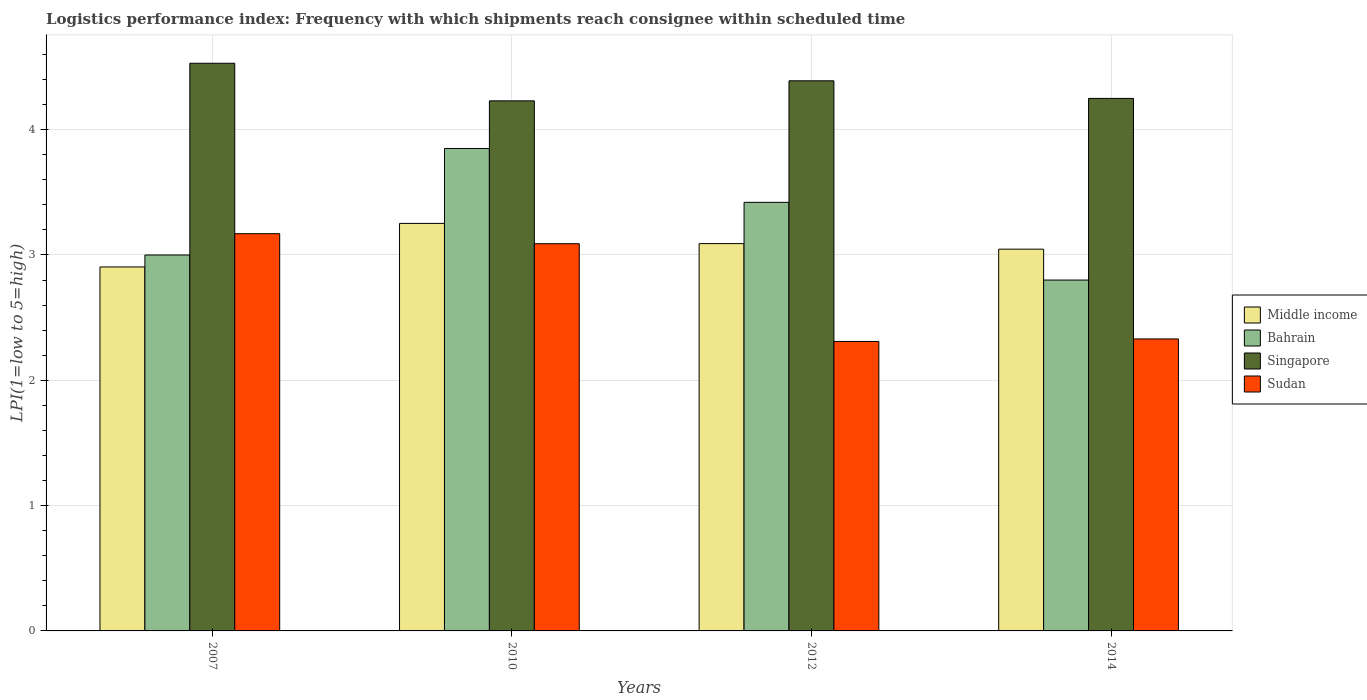How many different coloured bars are there?
Your answer should be very brief. 4. Are the number of bars per tick equal to the number of legend labels?
Provide a succinct answer. Yes. Are the number of bars on each tick of the X-axis equal?
Your response must be concise. Yes. In how many cases, is the number of bars for a given year not equal to the number of legend labels?
Your answer should be very brief. 0. What is the logistics performance index in Singapore in 2010?
Keep it short and to the point. 4.23. Across all years, what is the maximum logistics performance index in Sudan?
Your answer should be very brief. 3.17. Across all years, what is the minimum logistics performance index in Sudan?
Provide a short and direct response. 2.31. What is the total logistics performance index in Sudan in the graph?
Offer a terse response. 10.9. What is the difference between the logistics performance index in Sudan in 2012 and that in 2014?
Keep it short and to the point. -0.02. What is the difference between the logistics performance index in Middle income in 2014 and the logistics performance index in Singapore in 2012?
Offer a terse response. -1.34. What is the average logistics performance index in Sudan per year?
Provide a succinct answer. 2.73. In the year 2007, what is the difference between the logistics performance index in Middle income and logistics performance index in Bahrain?
Your answer should be compact. -0.1. In how many years, is the logistics performance index in Bahrain greater than 3?
Provide a short and direct response. 2. What is the ratio of the logistics performance index in Middle income in 2012 to that in 2014?
Provide a succinct answer. 1.01. Is the logistics performance index in Singapore in 2007 less than that in 2012?
Keep it short and to the point. No. What is the difference between the highest and the second highest logistics performance index in Middle income?
Offer a very short reply. 0.16. What is the difference between the highest and the lowest logistics performance index in Singapore?
Your response must be concise. 0.3. Is the sum of the logistics performance index in Singapore in 2007 and 2010 greater than the maximum logistics performance index in Bahrain across all years?
Provide a succinct answer. Yes. Is it the case that in every year, the sum of the logistics performance index in Sudan and logistics performance index in Singapore is greater than the sum of logistics performance index in Bahrain and logistics performance index in Middle income?
Your response must be concise. Yes. What does the 2nd bar from the left in 2010 represents?
Keep it short and to the point. Bahrain. What does the 2nd bar from the right in 2012 represents?
Offer a terse response. Singapore. Is it the case that in every year, the sum of the logistics performance index in Sudan and logistics performance index in Bahrain is greater than the logistics performance index in Singapore?
Offer a very short reply. Yes. How many bars are there?
Provide a short and direct response. 16. Are the values on the major ticks of Y-axis written in scientific E-notation?
Offer a terse response. No. Does the graph contain grids?
Your answer should be compact. Yes. How are the legend labels stacked?
Offer a very short reply. Vertical. What is the title of the graph?
Make the answer very short. Logistics performance index: Frequency with which shipments reach consignee within scheduled time. What is the label or title of the X-axis?
Provide a succinct answer. Years. What is the label or title of the Y-axis?
Your answer should be very brief. LPI(1=low to 5=high). What is the LPI(1=low to 5=high) of Middle income in 2007?
Ensure brevity in your answer.  2.9. What is the LPI(1=low to 5=high) of Bahrain in 2007?
Your answer should be very brief. 3. What is the LPI(1=low to 5=high) of Singapore in 2007?
Your answer should be very brief. 4.53. What is the LPI(1=low to 5=high) in Sudan in 2007?
Provide a short and direct response. 3.17. What is the LPI(1=low to 5=high) in Middle income in 2010?
Your response must be concise. 3.25. What is the LPI(1=low to 5=high) of Bahrain in 2010?
Your answer should be very brief. 3.85. What is the LPI(1=low to 5=high) in Singapore in 2010?
Provide a short and direct response. 4.23. What is the LPI(1=low to 5=high) in Sudan in 2010?
Offer a terse response. 3.09. What is the LPI(1=low to 5=high) of Middle income in 2012?
Your answer should be compact. 3.09. What is the LPI(1=low to 5=high) in Bahrain in 2012?
Make the answer very short. 3.42. What is the LPI(1=low to 5=high) in Singapore in 2012?
Provide a succinct answer. 4.39. What is the LPI(1=low to 5=high) of Sudan in 2012?
Your answer should be compact. 2.31. What is the LPI(1=low to 5=high) of Middle income in 2014?
Ensure brevity in your answer.  3.05. What is the LPI(1=low to 5=high) of Bahrain in 2014?
Provide a succinct answer. 2.8. What is the LPI(1=low to 5=high) in Singapore in 2014?
Make the answer very short. 4.25. What is the LPI(1=low to 5=high) in Sudan in 2014?
Your answer should be very brief. 2.33. Across all years, what is the maximum LPI(1=low to 5=high) in Middle income?
Your response must be concise. 3.25. Across all years, what is the maximum LPI(1=low to 5=high) of Bahrain?
Your answer should be compact. 3.85. Across all years, what is the maximum LPI(1=low to 5=high) in Singapore?
Make the answer very short. 4.53. Across all years, what is the maximum LPI(1=low to 5=high) of Sudan?
Offer a terse response. 3.17. Across all years, what is the minimum LPI(1=low to 5=high) in Middle income?
Your answer should be compact. 2.9. Across all years, what is the minimum LPI(1=low to 5=high) of Bahrain?
Provide a short and direct response. 2.8. Across all years, what is the minimum LPI(1=low to 5=high) in Singapore?
Give a very brief answer. 4.23. Across all years, what is the minimum LPI(1=low to 5=high) in Sudan?
Offer a terse response. 2.31. What is the total LPI(1=low to 5=high) in Middle income in the graph?
Your answer should be compact. 12.29. What is the total LPI(1=low to 5=high) in Bahrain in the graph?
Your answer should be compact. 13.07. What is the total LPI(1=low to 5=high) in Singapore in the graph?
Your answer should be compact. 17.4. What is the total LPI(1=low to 5=high) of Sudan in the graph?
Make the answer very short. 10.9. What is the difference between the LPI(1=low to 5=high) of Middle income in 2007 and that in 2010?
Make the answer very short. -0.35. What is the difference between the LPI(1=low to 5=high) of Bahrain in 2007 and that in 2010?
Offer a very short reply. -0.85. What is the difference between the LPI(1=low to 5=high) of Singapore in 2007 and that in 2010?
Your response must be concise. 0.3. What is the difference between the LPI(1=low to 5=high) of Middle income in 2007 and that in 2012?
Your answer should be compact. -0.19. What is the difference between the LPI(1=low to 5=high) of Bahrain in 2007 and that in 2012?
Provide a succinct answer. -0.42. What is the difference between the LPI(1=low to 5=high) of Singapore in 2007 and that in 2012?
Offer a very short reply. 0.14. What is the difference between the LPI(1=low to 5=high) in Sudan in 2007 and that in 2012?
Provide a succinct answer. 0.86. What is the difference between the LPI(1=low to 5=high) in Middle income in 2007 and that in 2014?
Offer a very short reply. -0.14. What is the difference between the LPI(1=low to 5=high) in Singapore in 2007 and that in 2014?
Offer a terse response. 0.28. What is the difference between the LPI(1=low to 5=high) in Sudan in 2007 and that in 2014?
Your answer should be very brief. 0.84. What is the difference between the LPI(1=low to 5=high) in Middle income in 2010 and that in 2012?
Your answer should be compact. 0.16. What is the difference between the LPI(1=low to 5=high) in Bahrain in 2010 and that in 2012?
Offer a terse response. 0.43. What is the difference between the LPI(1=low to 5=high) in Singapore in 2010 and that in 2012?
Offer a terse response. -0.16. What is the difference between the LPI(1=low to 5=high) of Sudan in 2010 and that in 2012?
Offer a very short reply. 0.78. What is the difference between the LPI(1=low to 5=high) in Middle income in 2010 and that in 2014?
Offer a very short reply. 0.21. What is the difference between the LPI(1=low to 5=high) of Singapore in 2010 and that in 2014?
Make the answer very short. -0.02. What is the difference between the LPI(1=low to 5=high) in Sudan in 2010 and that in 2014?
Your response must be concise. 0.76. What is the difference between the LPI(1=low to 5=high) in Middle income in 2012 and that in 2014?
Offer a terse response. 0.04. What is the difference between the LPI(1=low to 5=high) of Bahrain in 2012 and that in 2014?
Keep it short and to the point. 0.62. What is the difference between the LPI(1=low to 5=high) in Singapore in 2012 and that in 2014?
Your answer should be very brief. 0.14. What is the difference between the LPI(1=low to 5=high) of Sudan in 2012 and that in 2014?
Keep it short and to the point. -0.02. What is the difference between the LPI(1=low to 5=high) in Middle income in 2007 and the LPI(1=low to 5=high) in Bahrain in 2010?
Your answer should be compact. -0.95. What is the difference between the LPI(1=low to 5=high) in Middle income in 2007 and the LPI(1=low to 5=high) in Singapore in 2010?
Keep it short and to the point. -1.33. What is the difference between the LPI(1=low to 5=high) in Middle income in 2007 and the LPI(1=low to 5=high) in Sudan in 2010?
Offer a very short reply. -0.19. What is the difference between the LPI(1=low to 5=high) of Bahrain in 2007 and the LPI(1=low to 5=high) of Singapore in 2010?
Give a very brief answer. -1.23. What is the difference between the LPI(1=low to 5=high) of Bahrain in 2007 and the LPI(1=low to 5=high) of Sudan in 2010?
Your answer should be very brief. -0.09. What is the difference between the LPI(1=low to 5=high) in Singapore in 2007 and the LPI(1=low to 5=high) in Sudan in 2010?
Ensure brevity in your answer.  1.44. What is the difference between the LPI(1=low to 5=high) in Middle income in 2007 and the LPI(1=low to 5=high) in Bahrain in 2012?
Your answer should be very brief. -0.52. What is the difference between the LPI(1=low to 5=high) of Middle income in 2007 and the LPI(1=low to 5=high) of Singapore in 2012?
Make the answer very short. -1.49. What is the difference between the LPI(1=low to 5=high) of Middle income in 2007 and the LPI(1=low to 5=high) of Sudan in 2012?
Keep it short and to the point. 0.59. What is the difference between the LPI(1=low to 5=high) of Bahrain in 2007 and the LPI(1=low to 5=high) of Singapore in 2012?
Make the answer very short. -1.39. What is the difference between the LPI(1=low to 5=high) in Bahrain in 2007 and the LPI(1=low to 5=high) in Sudan in 2012?
Provide a succinct answer. 0.69. What is the difference between the LPI(1=low to 5=high) in Singapore in 2007 and the LPI(1=low to 5=high) in Sudan in 2012?
Offer a very short reply. 2.22. What is the difference between the LPI(1=low to 5=high) of Middle income in 2007 and the LPI(1=low to 5=high) of Bahrain in 2014?
Keep it short and to the point. 0.1. What is the difference between the LPI(1=low to 5=high) of Middle income in 2007 and the LPI(1=low to 5=high) of Singapore in 2014?
Offer a terse response. -1.35. What is the difference between the LPI(1=low to 5=high) of Middle income in 2007 and the LPI(1=low to 5=high) of Sudan in 2014?
Make the answer very short. 0.57. What is the difference between the LPI(1=low to 5=high) in Bahrain in 2007 and the LPI(1=low to 5=high) in Singapore in 2014?
Make the answer very short. -1.25. What is the difference between the LPI(1=low to 5=high) of Bahrain in 2007 and the LPI(1=low to 5=high) of Sudan in 2014?
Your response must be concise. 0.67. What is the difference between the LPI(1=low to 5=high) in Singapore in 2007 and the LPI(1=low to 5=high) in Sudan in 2014?
Keep it short and to the point. 2.2. What is the difference between the LPI(1=low to 5=high) in Middle income in 2010 and the LPI(1=low to 5=high) in Bahrain in 2012?
Offer a very short reply. -0.17. What is the difference between the LPI(1=low to 5=high) of Middle income in 2010 and the LPI(1=low to 5=high) of Singapore in 2012?
Offer a very short reply. -1.14. What is the difference between the LPI(1=low to 5=high) of Middle income in 2010 and the LPI(1=low to 5=high) of Sudan in 2012?
Give a very brief answer. 0.94. What is the difference between the LPI(1=low to 5=high) of Bahrain in 2010 and the LPI(1=low to 5=high) of Singapore in 2012?
Keep it short and to the point. -0.54. What is the difference between the LPI(1=low to 5=high) in Bahrain in 2010 and the LPI(1=low to 5=high) in Sudan in 2012?
Offer a terse response. 1.54. What is the difference between the LPI(1=low to 5=high) of Singapore in 2010 and the LPI(1=low to 5=high) of Sudan in 2012?
Provide a short and direct response. 1.92. What is the difference between the LPI(1=low to 5=high) of Middle income in 2010 and the LPI(1=low to 5=high) of Bahrain in 2014?
Ensure brevity in your answer.  0.45. What is the difference between the LPI(1=low to 5=high) of Middle income in 2010 and the LPI(1=low to 5=high) of Singapore in 2014?
Offer a terse response. -1. What is the difference between the LPI(1=low to 5=high) of Middle income in 2010 and the LPI(1=low to 5=high) of Sudan in 2014?
Make the answer very short. 0.92. What is the difference between the LPI(1=low to 5=high) in Bahrain in 2010 and the LPI(1=low to 5=high) in Singapore in 2014?
Ensure brevity in your answer.  -0.4. What is the difference between the LPI(1=low to 5=high) in Bahrain in 2010 and the LPI(1=low to 5=high) in Sudan in 2014?
Your answer should be compact. 1.52. What is the difference between the LPI(1=low to 5=high) of Singapore in 2010 and the LPI(1=low to 5=high) of Sudan in 2014?
Provide a succinct answer. 1.9. What is the difference between the LPI(1=low to 5=high) in Middle income in 2012 and the LPI(1=low to 5=high) in Bahrain in 2014?
Keep it short and to the point. 0.29. What is the difference between the LPI(1=low to 5=high) of Middle income in 2012 and the LPI(1=low to 5=high) of Singapore in 2014?
Provide a short and direct response. -1.16. What is the difference between the LPI(1=low to 5=high) of Middle income in 2012 and the LPI(1=low to 5=high) of Sudan in 2014?
Your answer should be compact. 0.76. What is the difference between the LPI(1=low to 5=high) in Bahrain in 2012 and the LPI(1=low to 5=high) in Singapore in 2014?
Your answer should be very brief. -0.83. What is the difference between the LPI(1=low to 5=high) in Bahrain in 2012 and the LPI(1=low to 5=high) in Sudan in 2014?
Make the answer very short. 1.09. What is the difference between the LPI(1=low to 5=high) of Singapore in 2012 and the LPI(1=low to 5=high) of Sudan in 2014?
Make the answer very short. 2.06. What is the average LPI(1=low to 5=high) of Middle income per year?
Keep it short and to the point. 3.07. What is the average LPI(1=low to 5=high) in Bahrain per year?
Keep it short and to the point. 3.27. What is the average LPI(1=low to 5=high) in Singapore per year?
Give a very brief answer. 4.35. What is the average LPI(1=low to 5=high) in Sudan per year?
Your answer should be compact. 2.73. In the year 2007, what is the difference between the LPI(1=low to 5=high) in Middle income and LPI(1=low to 5=high) in Bahrain?
Make the answer very short. -0.1. In the year 2007, what is the difference between the LPI(1=low to 5=high) of Middle income and LPI(1=low to 5=high) of Singapore?
Provide a short and direct response. -1.63. In the year 2007, what is the difference between the LPI(1=low to 5=high) in Middle income and LPI(1=low to 5=high) in Sudan?
Offer a terse response. -0.27. In the year 2007, what is the difference between the LPI(1=low to 5=high) of Bahrain and LPI(1=low to 5=high) of Singapore?
Provide a succinct answer. -1.53. In the year 2007, what is the difference between the LPI(1=low to 5=high) in Bahrain and LPI(1=low to 5=high) in Sudan?
Offer a very short reply. -0.17. In the year 2007, what is the difference between the LPI(1=low to 5=high) in Singapore and LPI(1=low to 5=high) in Sudan?
Your response must be concise. 1.36. In the year 2010, what is the difference between the LPI(1=low to 5=high) of Middle income and LPI(1=low to 5=high) of Bahrain?
Your response must be concise. -0.6. In the year 2010, what is the difference between the LPI(1=low to 5=high) of Middle income and LPI(1=low to 5=high) of Singapore?
Make the answer very short. -0.98. In the year 2010, what is the difference between the LPI(1=low to 5=high) in Middle income and LPI(1=low to 5=high) in Sudan?
Give a very brief answer. 0.16. In the year 2010, what is the difference between the LPI(1=low to 5=high) in Bahrain and LPI(1=low to 5=high) in Singapore?
Ensure brevity in your answer.  -0.38. In the year 2010, what is the difference between the LPI(1=low to 5=high) in Bahrain and LPI(1=low to 5=high) in Sudan?
Offer a terse response. 0.76. In the year 2010, what is the difference between the LPI(1=low to 5=high) of Singapore and LPI(1=low to 5=high) of Sudan?
Keep it short and to the point. 1.14. In the year 2012, what is the difference between the LPI(1=low to 5=high) of Middle income and LPI(1=low to 5=high) of Bahrain?
Keep it short and to the point. -0.33. In the year 2012, what is the difference between the LPI(1=low to 5=high) in Middle income and LPI(1=low to 5=high) in Singapore?
Your answer should be very brief. -1.3. In the year 2012, what is the difference between the LPI(1=low to 5=high) of Middle income and LPI(1=low to 5=high) of Sudan?
Give a very brief answer. 0.78. In the year 2012, what is the difference between the LPI(1=low to 5=high) of Bahrain and LPI(1=low to 5=high) of Singapore?
Your answer should be compact. -0.97. In the year 2012, what is the difference between the LPI(1=low to 5=high) of Bahrain and LPI(1=low to 5=high) of Sudan?
Keep it short and to the point. 1.11. In the year 2012, what is the difference between the LPI(1=low to 5=high) of Singapore and LPI(1=low to 5=high) of Sudan?
Offer a very short reply. 2.08. In the year 2014, what is the difference between the LPI(1=low to 5=high) in Middle income and LPI(1=low to 5=high) in Bahrain?
Ensure brevity in your answer.  0.25. In the year 2014, what is the difference between the LPI(1=low to 5=high) of Middle income and LPI(1=low to 5=high) of Singapore?
Provide a short and direct response. -1.2. In the year 2014, what is the difference between the LPI(1=low to 5=high) of Middle income and LPI(1=low to 5=high) of Sudan?
Offer a very short reply. 0.72. In the year 2014, what is the difference between the LPI(1=low to 5=high) in Bahrain and LPI(1=low to 5=high) in Singapore?
Your response must be concise. -1.45. In the year 2014, what is the difference between the LPI(1=low to 5=high) in Bahrain and LPI(1=low to 5=high) in Sudan?
Your response must be concise. 0.47. In the year 2014, what is the difference between the LPI(1=low to 5=high) of Singapore and LPI(1=low to 5=high) of Sudan?
Your answer should be very brief. 1.92. What is the ratio of the LPI(1=low to 5=high) of Middle income in 2007 to that in 2010?
Offer a very short reply. 0.89. What is the ratio of the LPI(1=low to 5=high) in Bahrain in 2007 to that in 2010?
Your response must be concise. 0.78. What is the ratio of the LPI(1=low to 5=high) in Singapore in 2007 to that in 2010?
Make the answer very short. 1.07. What is the ratio of the LPI(1=low to 5=high) in Sudan in 2007 to that in 2010?
Make the answer very short. 1.03. What is the ratio of the LPI(1=low to 5=high) in Middle income in 2007 to that in 2012?
Give a very brief answer. 0.94. What is the ratio of the LPI(1=low to 5=high) of Bahrain in 2007 to that in 2012?
Give a very brief answer. 0.88. What is the ratio of the LPI(1=low to 5=high) of Singapore in 2007 to that in 2012?
Offer a very short reply. 1.03. What is the ratio of the LPI(1=low to 5=high) of Sudan in 2007 to that in 2012?
Ensure brevity in your answer.  1.37. What is the ratio of the LPI(1=low to 5=high) of Middle income in 2007 to that in 2014?
Your answer should be compact. 0.95. What is the ratio of the LPI(1=low to 5=high) in Bahrain in 2007 to that in 2014?
Offer a terse response. 1.07. What is the ratio of the LPI(1=low to 5=high) of Singapore in 2007 to that in 2014?
Provide a short and direct response. 1.07. What is the ratio of the LPI(1=low to 5=high) in Sudan in 2007 to that in 2014?
Make the answer very short. 1.36. What is the ratio of the LPI(1=low to 5=high) of Middle income in 2010 to that in 2012?
Make the answer very short. 1.05. What is the ratio of the LPI(1=low to 5=high) in Bahrain in 2010 to that in 2012?
Offer a terse response. 1.13. What is the ratio of the LPI(1=low to 5=high) of Singapore in 2010 to that in 2012?
Your response must be concise. 0.96. What is the ratio of the LPI(1=low to 5=high) in Sudan in 2010 to that in 2012?
Offer a terse response. 1.34. What is the ratio of the LPI(1=low to 5=high) in Middle income in 2010 to that in 2014?
Your answer should be compact. 1.07. What is the ratio of the LPI(1=low to 5=high) of Bahrain in 2010 to that in 2014?
Offer a terse response. 1.38. What is the ratio of the LPI(1=low to 5=high) of Sudan in 2010 to that in 2014?
Your answer should be compact. 1.33. What is the ratio of the LPI(1=low to 5=high) in Middle income in 2012 to that in 2014?
Offer a terse response. 1.01. What is the ratio of the LPI(1=low to 5=high) in Bahrain in 2012 to that in 2014?
Provide a short and direct response. 1.22. What is the ratio of the LPI(1=low to 5=high) in Singapore in 2012 to that in 2014?
Keep it short and to the point. 1.03. What is the difference between the highest and the second highest LPI(1=low to 5=high) of Middle income?
Give a very brief answer. 0.16. What is the difference between the highest and the second highest LPI(1=low to 5=high) of Bahrain?
Keep it short and to the point. 0.43. What is the difference between the highest and the second highest LPI(1=low to 5=high) in Singapore?
Keep it short and to the point. 0.14. What is the difference between the highest and the lowest LPI(1=low to 5=high) in Middle income?
Offer a very short reply. 0.35. What is the difference between the highest and the lowest LPI(1=low to 5=high) of Singapore?
Offer a terse response. 0.3. What is the difference between the highest and the lowest LPI(1=low to 5=high) of Sudan?
Ensure brevity in your answer.  0.86. 